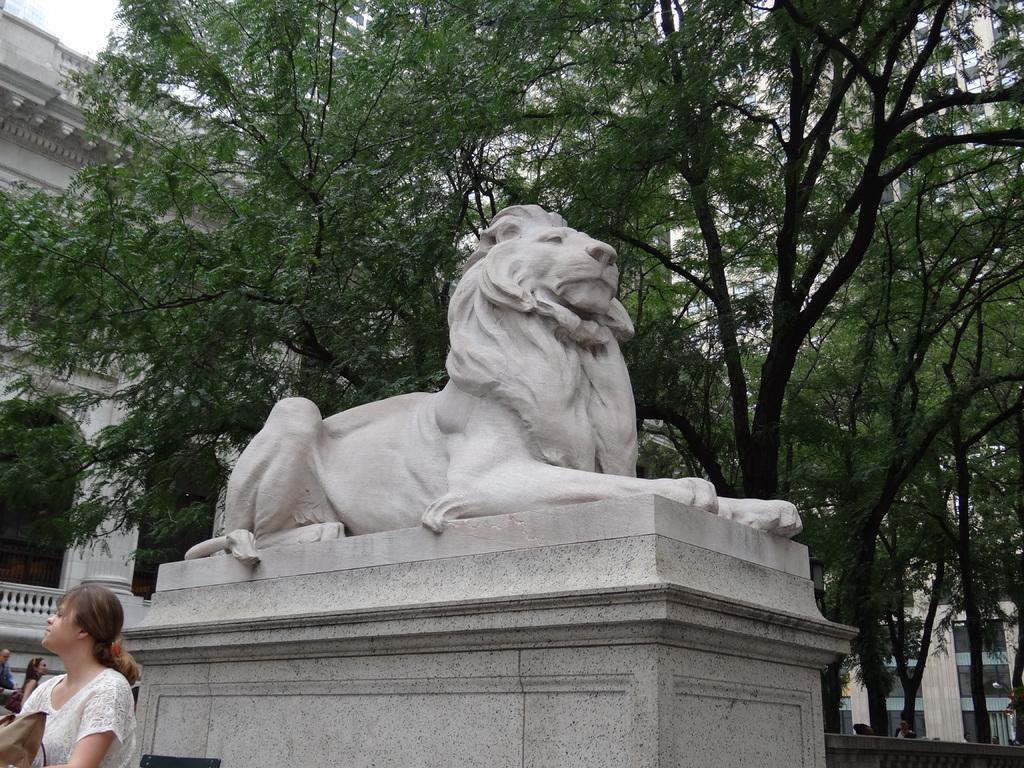In one or two sentences, can you explain what this image depicts? In this image I can see the statue of an animal. To the side I can see few people with different color dresses. In the background I can see many trees, buildings and the sky. 